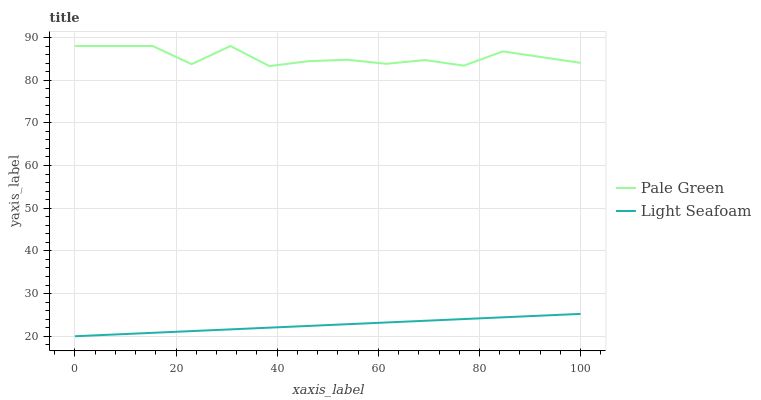Does Light Seafoam have the maximum area under the curve?
Answer yes or no. No. Is Light Seafoam the roughest?
Answer yes or no. No. Does Light Seafoam have the highest value?
Answer yes or no. No. Is Light Seafoam less than Pale Green?
Answer yes or no. Yes. Is Pale Green greater than Light Seafoam?
Answer yes or no. Yes. Does Light Seafoam intersect Pale Green?
Answer yes or no. No. 